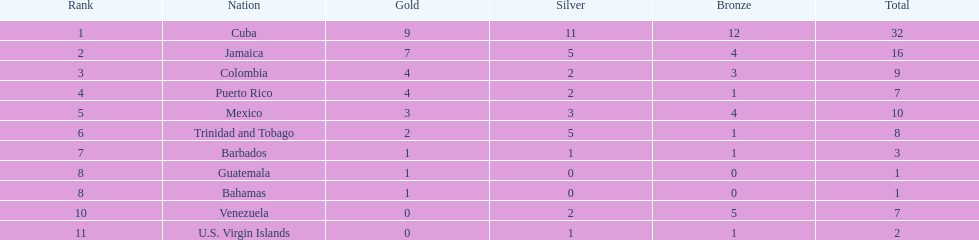Which two countries have the greatest difference in the number of medals won? 31. 